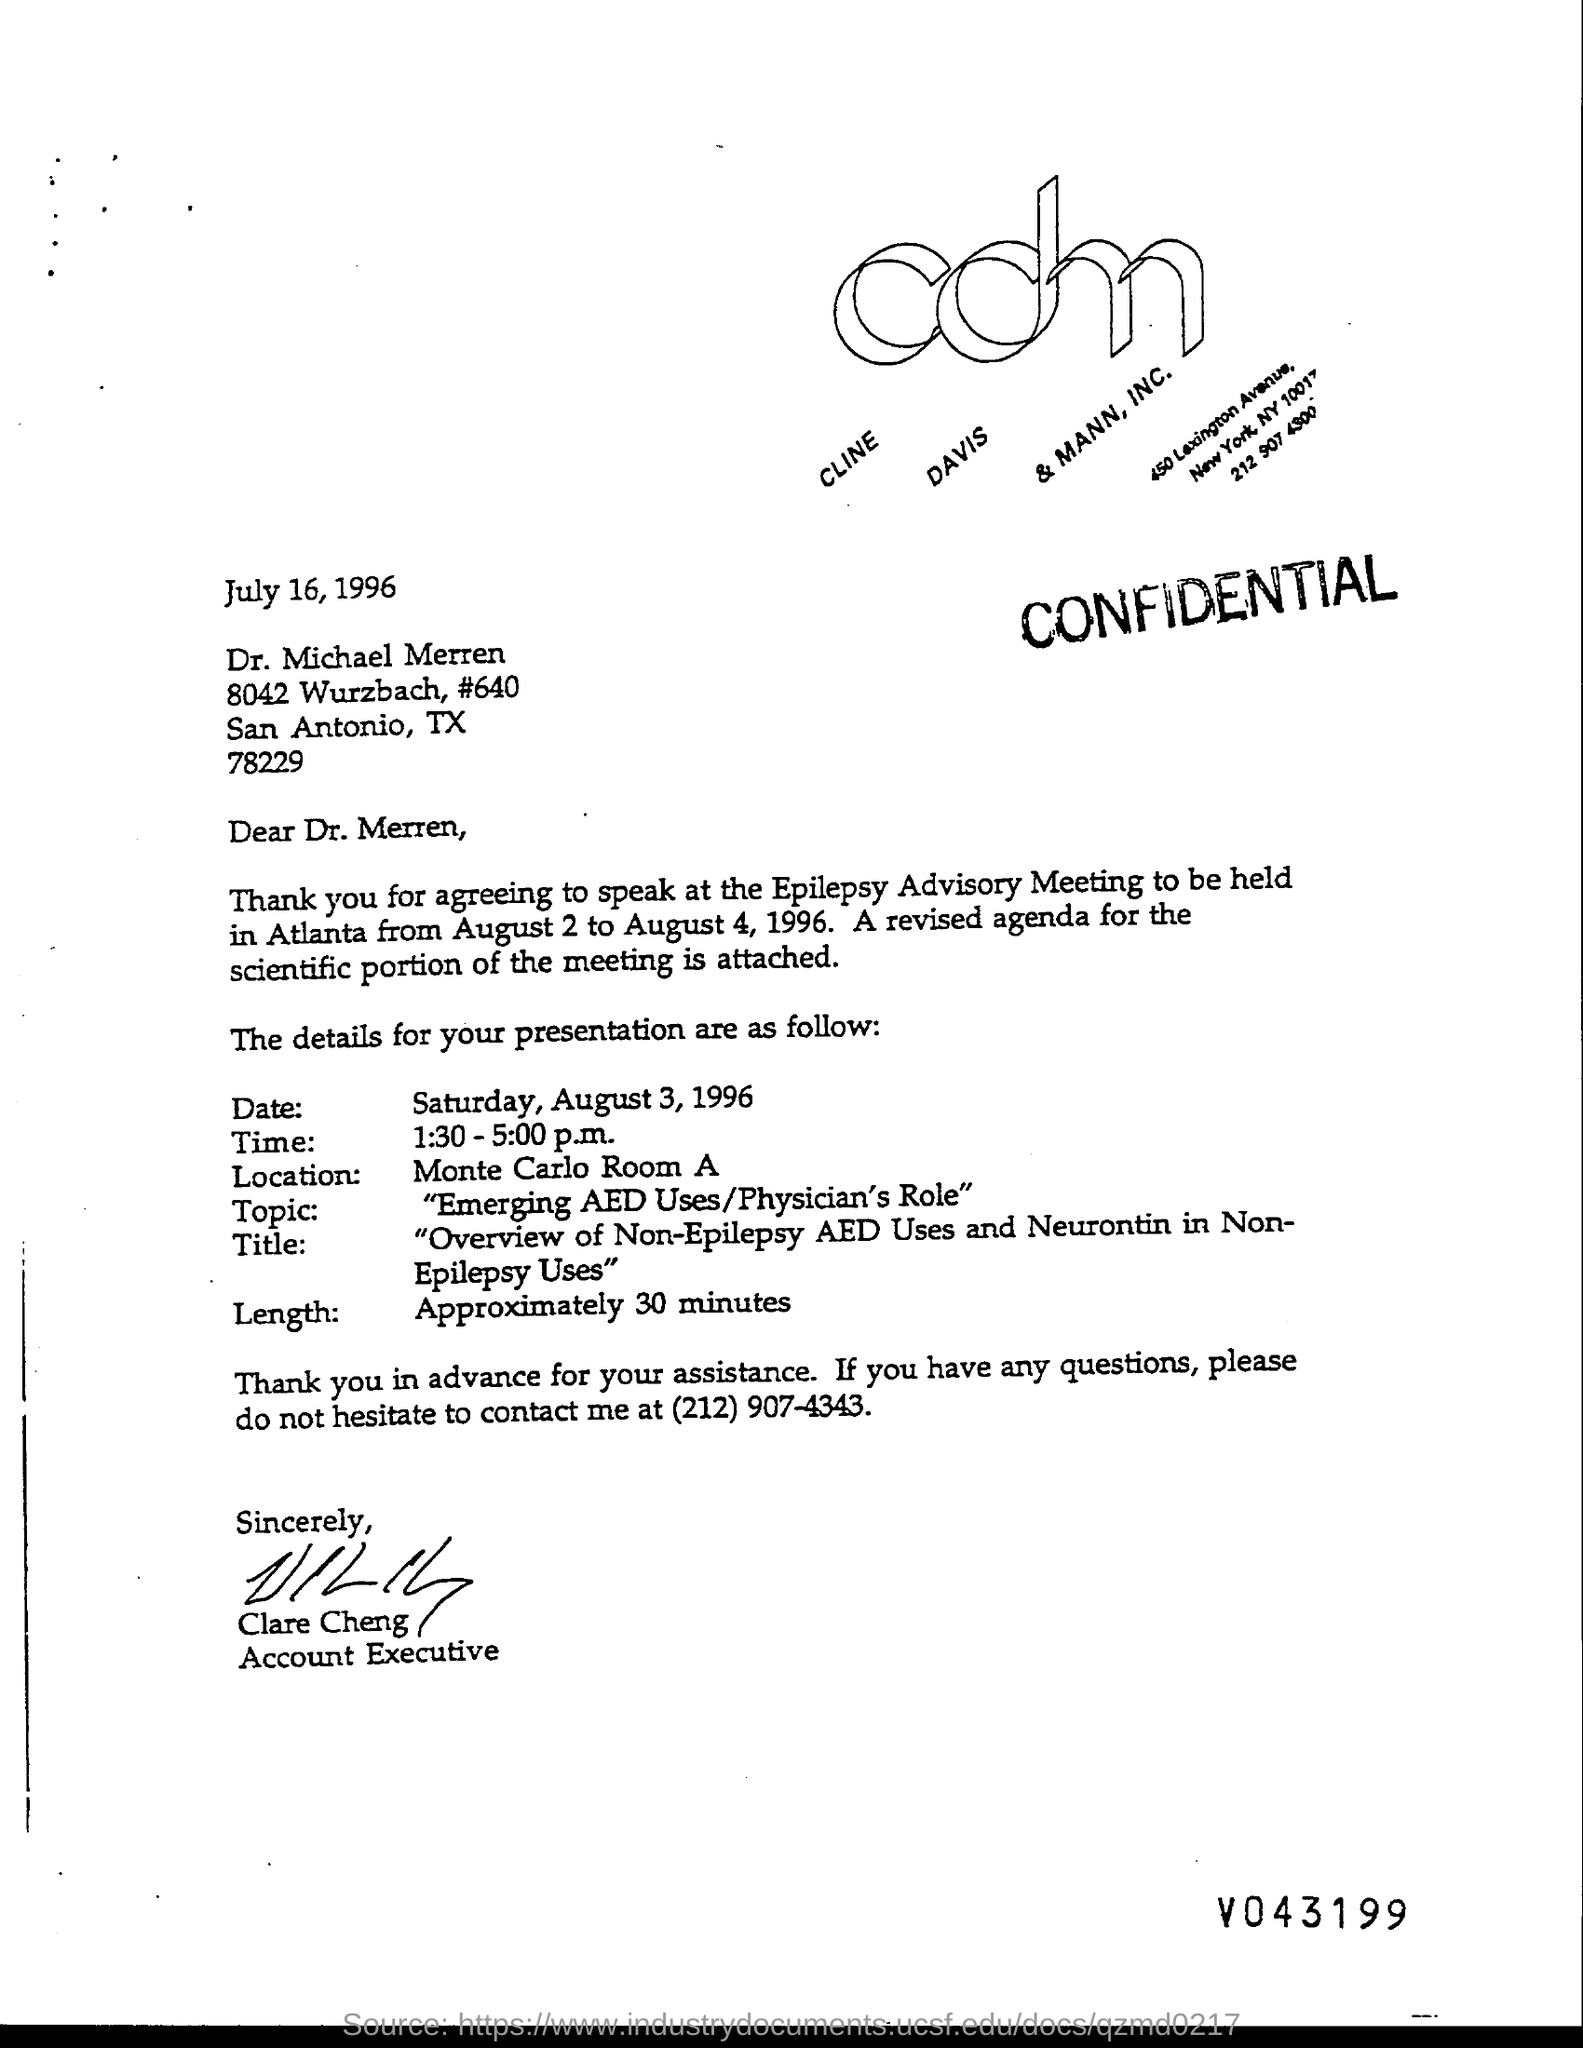Indicate a few pertinent items in this graphic. The length of the video is approximately 30 minutes. Clare Cheng is the account executive. The location is named Monte Carlo Room A.. 